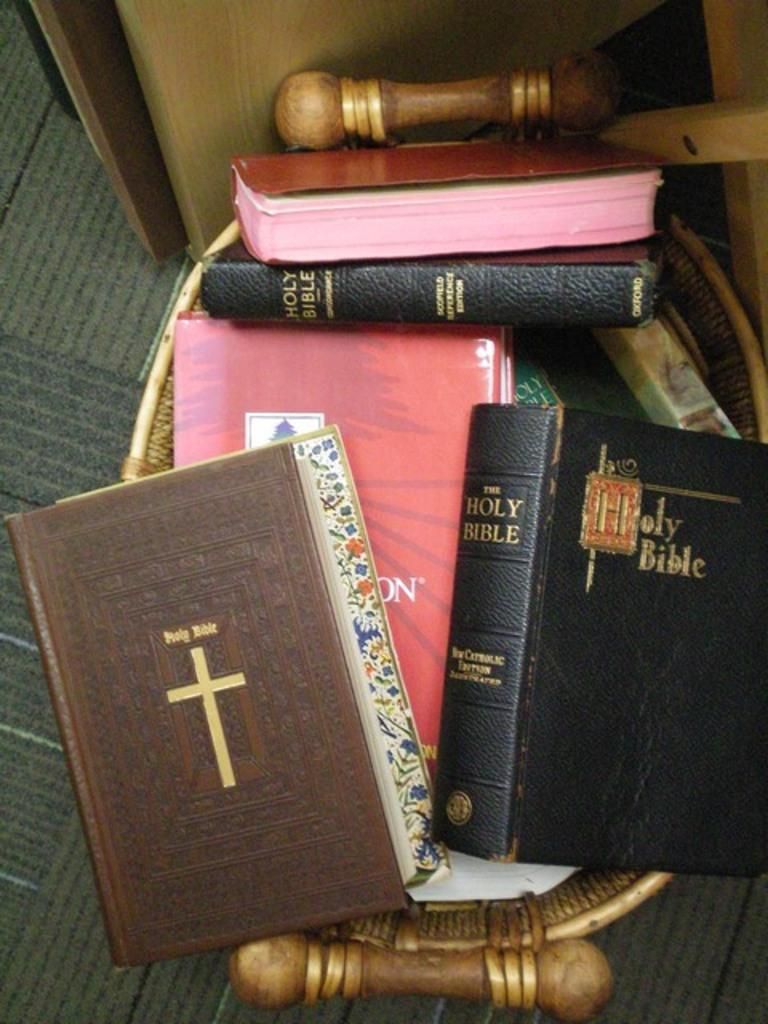<image>
Describe the image concisely. A stack of different versions of the Holy Bible sitting on a stool. 